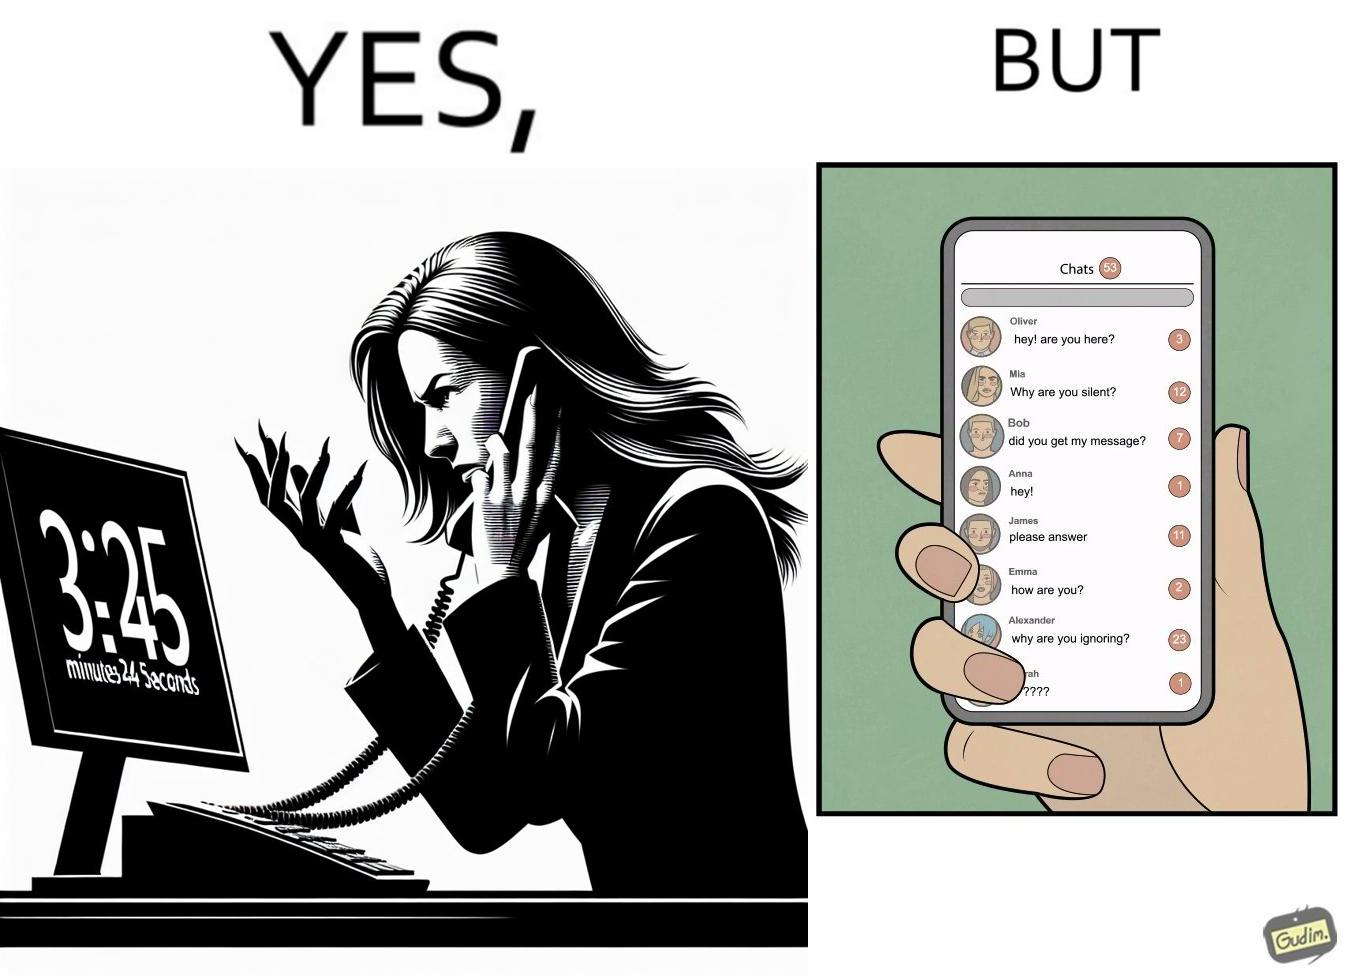Explain the humor or irony in this image. The image is ironical because while the woman is annoyed by the unresponsiveness of the call center, she herself is being unresponsive to many people in the chat. 